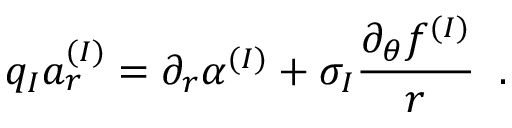Convert formula to latex. <formula><loc_0><loc_0><loc_500><loc_500>q _ { I } a _ { r } ^ { ( I ) } = \partial _ { r } \alpha ^ { ( I ) } + \sigma _ { I } \frac { \partial _ { \theta } f ^ { ( I ) } } { r } \, .</formula> 